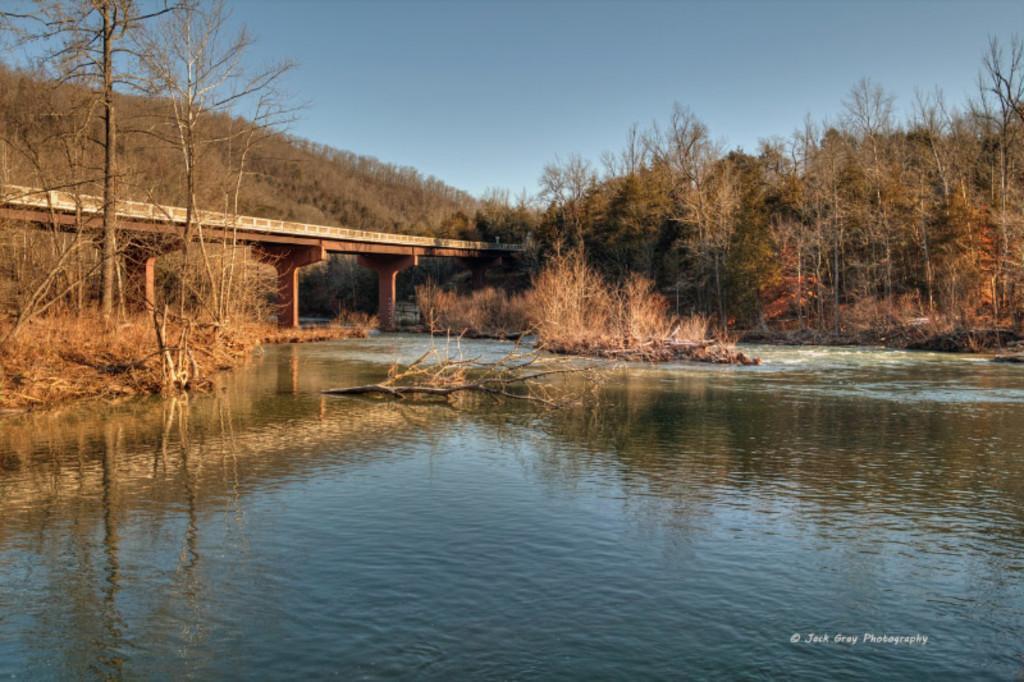Could you give a brief overview of what you see in this image? In this picture there is a bridge near to the mountain. On the mountain we can see many trees. At the bottom there is a river. In the bottom right corner there is a watermark. At the top there is a sky. On the left we can see the grass and leaves. 